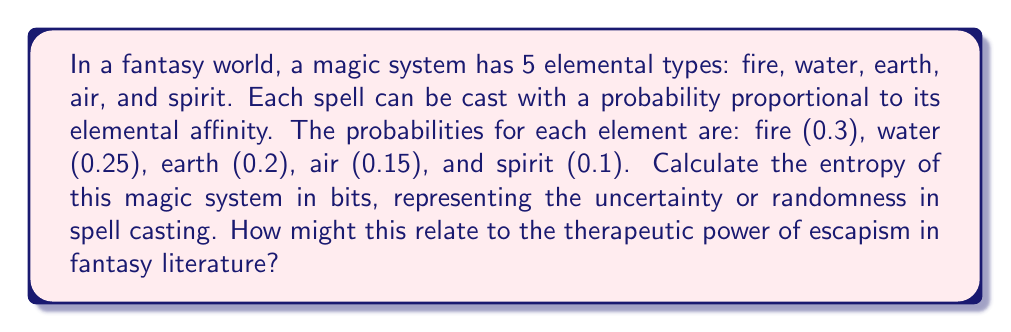Teach me how to tackle this problem. To calculate the entropy of this magic system, we'll use the Shannon entropy formula:

$$S = -\sum_{i=1}^n p_i \log_2(p_i)$$

Where $S$ is the entropy, $p_i$ is the probability of each outcome, and $n$ is the number of possible outcomes.

Step 1: List the probabilities
$p_1 = 0.3$ (fire)
$p_2 = 0.25$ (water)
$p_3 = 0.2$ (earth)
$p_4 = 0.15$ (air)
$p_5 = 0.1$ (spirit)

Step 2: Calculate each term of the sum
Fire: $-0.3 \log_2(0.3) = 0.5211$
Water: $-0.25 \log_2(0.25) = 0.5$
Earth: $-0.2 \log_2(0.2) = 0.4644$
Air: $-0.15 \log_2(0.15) = 0.4101$
Spirit: $-0.1 \log_2(0.1) = 0.3322$

Step 3: Sum all terms
$$S = 0.5211 + 0.5 + 0.4644 + 0.4101 + 0.3322 = 2.2278 \text{ bits}$$

This entropy value represents the average amount of information or uncertainty in the magic system. A higher entropy indicates more randomness and unpredictability in spell casting, which can contribute to the sense of wonder and escapism in fantasy literature. The variety and unpredictability of magic can provide a therapeutic escape from the structured and sometimes mundane aspects of real life, offering readers a sense of excitement and possibility.
Answer: 2.2278 bits 